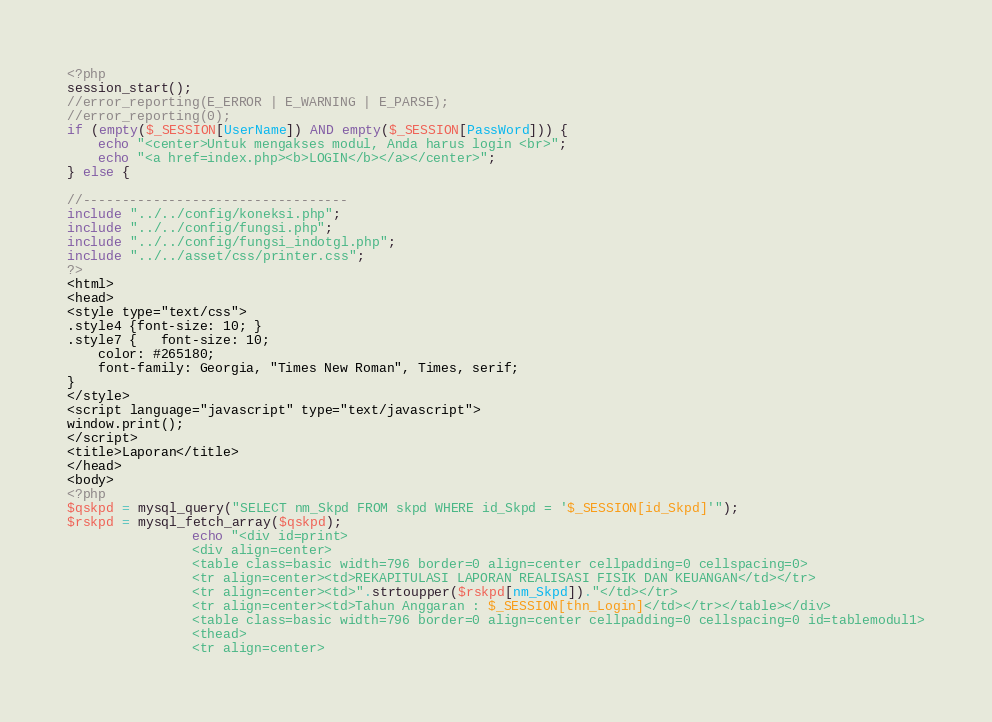Convert code to text. <code><loc_0><loc_0><loc_500><loc_500><_PHP_><?php
session_start();
//error_reporting(E_ERROR | E_WARNING | E_PARSE);
//error_reporting(0);
if (empty($_SESSION[UserName]) AND empty($_SESSION[PassWord])) {
    echo "<center>Untuk mengakses modul, Anda harus login <br>";
    echo "<a href=index.php><b>LOGIN</b></a></center>";
} else {

//----------------------------------
include "../../config/koneksi.php";
include "../../config/fungsi.php";
include "../../config/fungsi_indotgl.php";
include "../../asset/css/printer.css";
?>
<html>
<head>
<style type="text/css">
.style4 {font-size: 10; }
.style7 {	font-size: 10;
	color: #265180;
	font-family: Georgia, "Times New Roman", Times, serif;
}
</style>
<script language="javascript" type="text/javascript">
window.print();
</script>
<title>Laporan</title>
</head>
<body>
<?php  
$qskpd = mysql_query("SELECT nm_Skpd FROM skpd WHERE id_Skpd = '$_SESSION[id_Skpd]'");
$rskpd = mysql_fetch_array($qskpd);
				echo "<div id=print>
				<div align=center>
				<table class=basic width=796 border=0 align=center cellpadding=0 cellspacing=0>
				<tr align=center><td>REKAPITULASI LAPORAN REALISASI FISIK DAN KEUANGAN</td></tr>
				<tr align=center><td>".strtoupper($rskpd[nm_Skpd])."</td></tr>
				<tr align=center><td>Tahun Anggaran : $_SESSION[thn_Login]</td></tr></table></div>	
	            <table class=basic width=796 border=0 align=center cellpadding=0 cellspacing=0 id=tablemodul1>
                <thead>
                <tr align=center></code> 